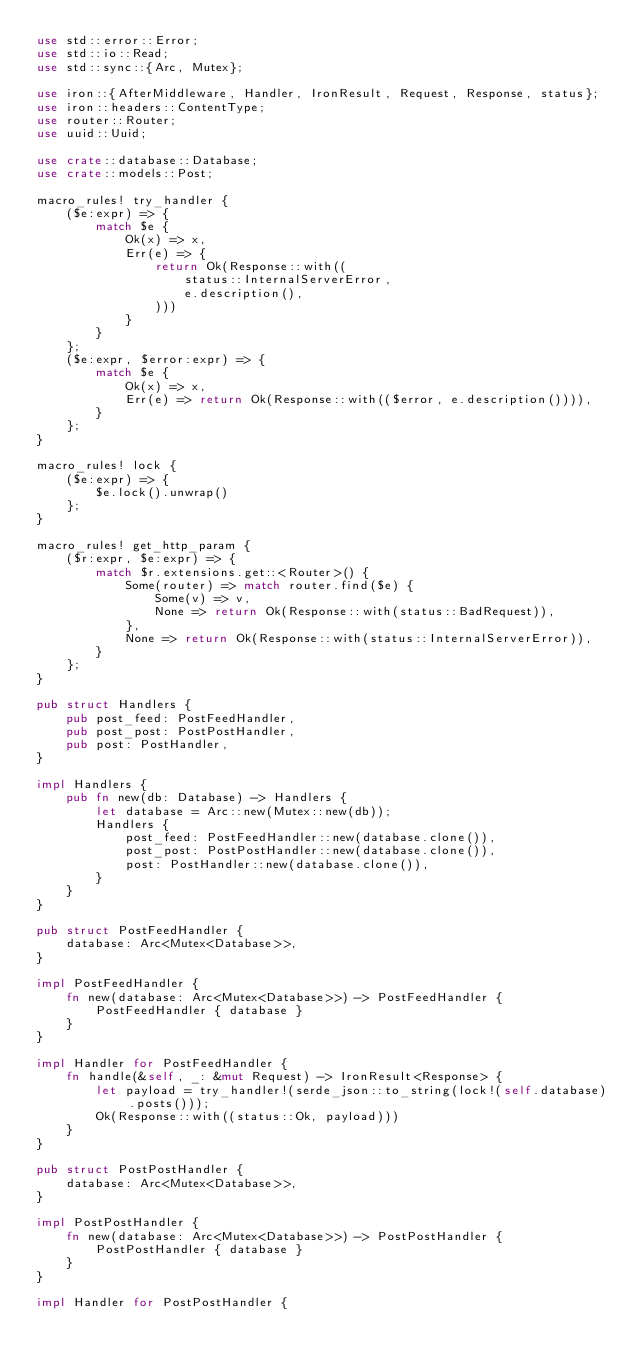<code> <loc_0><loc_0><loc_500><loc_500><_Rust_>use std::error::Error;
use std::io::Read;
use std::sync::{Arc, Mutex};

use iron::{AfterMiddleware, Handler, IronResult, Request, Response, status};
use iron::headers::ContentType;
use router::Router;
use uuid::Uuid;

use crate::database::Database;
use crate::models::Post;

macro_rules! try_handler {
    ($e:expr) => {
        match $e {
            Ok(x) => x,
            Err(e) => {
                return Ok(Response::with((
                    status::InternalServerError,
                    e.description(),
                )))
            }
        }
    };
    ($e:expr, $error:expr) => {
        match $e {
            Ok(x) => x,
            Err(e) => return Ok(Response::with(($error, e.description()))),
        }
    };
}

macro_rules! lock {
    ($e:expr) => {
        $e.lock().unwrap()
    };
}

macro_rules! get_http_param {
    ($r:expr, $e:expr) => {
        match $r.extensions.get::<Router>() {
            Some(router) => match router.find($e) {
                Some(v) => v,
                None => return Ok(Response::with(status::BadRequest)),
            },
            None => return Ok(Response::with(status::InternalServerError)),
        }
    };
}

pub struct Handlers {
    pub post_feed: PostFeedHandler,
    pub post_post: PostPostHandler,
    pub post: PostHandler,
}

impl Handlers {
    pub fn new(db: Database) -> Handlers {
        let database = Arc::new(Mutex::new(db));
        Handlers {
            post_feed: PostFeedHandler::new(database.clone()),
            post_post: PostPostHandler::new(database.clone()),
            post: PostHandler::new(database.clone()),
        }
    }
}

pub struct PostFeedHandler {
    database: Arc<Mutex<Database>>,
}

impl PostFeedHandler {
    fn new(database: Arc<Mutex<Database>>) -> PostFeedHandler {
        PostFeedHandler { database }
    }
}

impl Handler for PostFeedHandler {
    fn handle(&self, _: &mut Request) -> IronResult<Response> {
        let payload = try_handler!(serde_json::to_string(lock!(self.database).posts()));
        Ok(Response::with((status::Ok, payload)))
    }
}

pub struct PostPostHandler {
    database: Arc<Mutex<Database>>,
}

impl PostPostHandler {
    fn new(database: Arc<Mutex<Database>>) -> PostPostHandler {
        PostPostHandler { database }
    }
}

impl Handler for PostPostHandler {</code> 